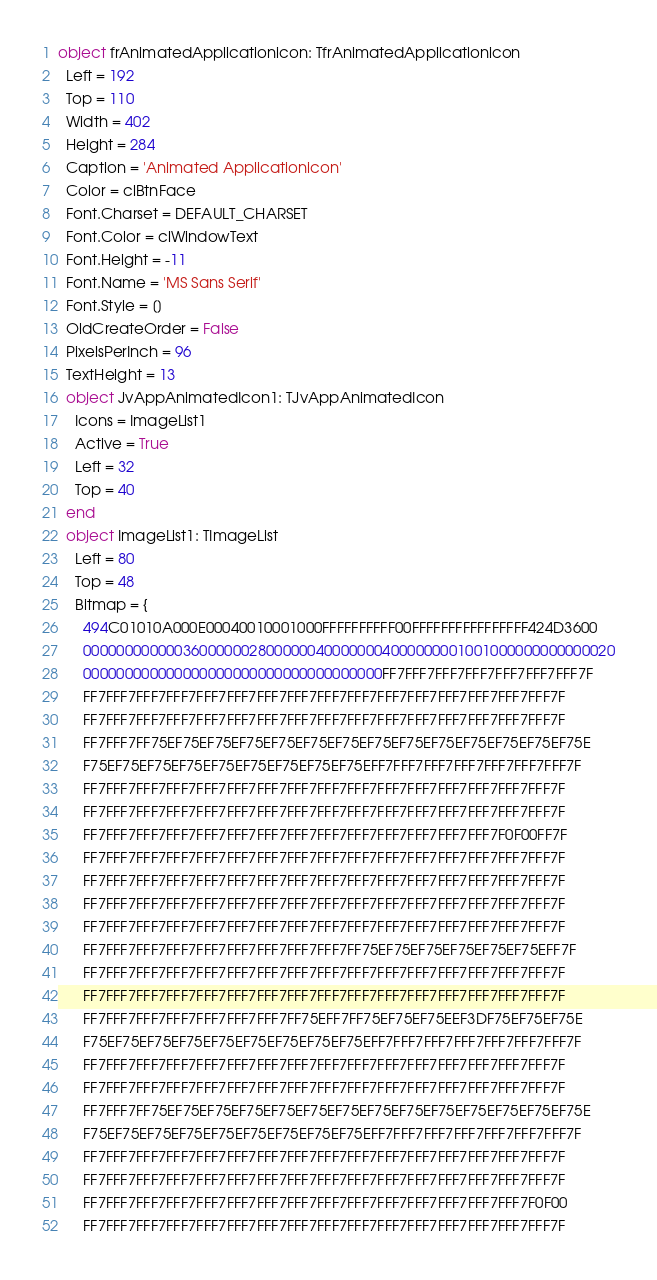Convert code to text. <code><loc_0><loc_0><loc_500><loc_500><_Pascal_>object frAnimatedApplicationicon: TfrAnimatedApplicationicon
  Left = 192
  Top = 110
  Width = 402
  Height = 284
  Caption = 'Animated Applicationicon'
  Color = clBtnFace
  Font.Charset = DEFAULT_CHARSET
  Font.Color = clWindowText
  Font.Height = -11
  Font.Name = 'MS Sans Serif'
  Font.Style = []
  OldCreateOrder = False
  PixelsPerInch = 96
  TextHeight = 13
  object JvAppAnimatedIcon1: TJvAppAnimatedIcon
    Icons = ImageList1
    Active = True
    Left = 32
    Top = 40
  end
  object ImageList1: TImageList
    Left = 80
    Top = 48
    Bitmap = {
      494C01010A000E00040010001000FFFFFFFFFF00FFFFFFFFFFFFFFFF424D3600
      0000000000003600000028000000400000004000000001001000000000000020
      000000000000000000000000000000000000FF7FFF7FFF7FFF7FFF7FFF7FFF7F
      FF7FFF7FFF7FFF7FFF7FFF7FFF7FFF7FFF7FFF7FFF7FFF7FFF7FFF7FFF7FFF7F
      FF7FFF7FFF7FFF7FFF7FFF7FFF7FFF7FFF7FFF7FFF7FFF7FFF7FFF7FFF7FFF7F
      FF7FFF7FF75EF75EF75EF75EF75EF75EF75EF75EF75EF75EF75EF75EF75EF75E
      F75EF75EF75EF75EF75EF75EF75EF75EF75EFF7FFF7FFF7FFF7FFF7FFF7FFF7F
      FF7FFF7FFF7FFF7FFF7FFF7FFF7FFF7FFF7FFF7FFF7FFF7FFF7FFF7FFF7FFF7F
      FF7FFF7FFF7FFF7FFF7FFF7FFF7FFF7FFF7FFF7FFF7FFF7FFF7FFF7FFF7FFF7F
      FF7FFF7FFF7FFF7FFF7FFF7FFF7FFF7FFF7FFF7FFF7FFF7FFF7FFF7F0F00FF7F
      FF7FFF7FFF7FFF7FFF7FFF7FFF7FFF7FFF7FFF7FFF7FFF7FFF7FFF7FFF7FFF7F
      FF7FFF7FFF7FFF7FFF7FFF7FFF7FFF7FFF7FFF7FFF7FFF7FFF7FFF7FFF7FFF7F
      FF7FFF7FFF7FFF7FFF7FFF7FFF7FFF7FFF7FFF7FFF7FFF7FFF7FFF7FFF7FFF7F
      FF7FFF7FFF7FFF7FFF7FFF7FFF7FFF7FFF7FFF7FFF7FFF7FFF7FFF7FFF7FFF7F
      FF7FFF7FFF7FFF7FFF7FFF7FFF7FFF7FFF7FF75EF75EF75EF75EF75EF75EFF7F
      FF7FFF7FFF7FFF7FFF7FFF7FFF7FFF7FFF7FFF7FFF7FFF7FFF7FFF7FFF7FFF7F
      FF7FFF7FFF7FFF7FFF7FFF7FFF7FFF7FFF7FFF7FFF7FFF7FFF7FFF7FFF7FFF7F
      FF7FFF7FFF7FFF7FFF7FFF7FFF7FF75EFF7FF75EF75EF75EEF3DF75EF75EF75E
      F75EF75EF75EF75EF75EF75EF75EF75EF75EFF7FFF7FFF7FFF7FFF7FFF7FFF7F
      FF7FFF7FFF7FFF7FFF7FFF7FFF7FFF7FFF7FFF7FFF7FFF7FFF7FFF7FFF7FFF7F
      FF7FFF7FFF7FFF7FFF7FFF7FFF7FFF7FFF7FFF7FFF7FFF7FFF7FFF7FFF7FFF7F
      FF7FFF7FF75EF75EF75EF75EF75EF75EF75EF75EF75EF75EF75EF75EF75EF75E
      F75EF75EF75EF75EF75EF75EF75EF75EF75EFF7FFF7FFF7FFF7FFF7FFF7FFF7F
      FF7FFF7FFF7FFF7FFF7FFF7FFF7FFF7FFF7FFF7FFF7FFF7FFF7FFF7FFF7FFF7F
      FF7FFF7FFF7FFF7FFF7FFF7FFF7FFF7FFF7FFF7FFF7FFF7FFF7FFF7FFF7FFF7F
      FF7FFF7FFF7FFF7FFF7FFF7FFF7FFF7FFF7FFF7FFF7FFF7FFF7FFF7FFF7F0F00
      FF7FFF7FFF7FFF7FFF7FFF7FFF7FFF7FFF7FFF7FFF7FFF7FFF7FFF7FFF7FFF7F</code> 